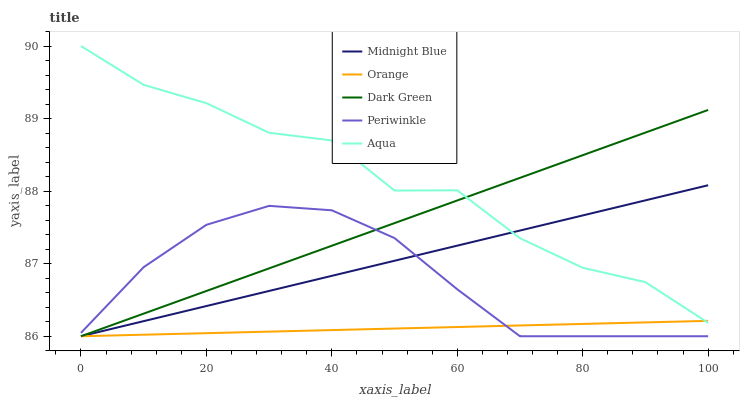Does Orange have the minimum area under the curve?
Answer yes or no. Yes. Does Aqua have the maximum area under the curve?
Answer yes or no. Yes. Does Periwinkle have the minimum area under the curve?
Answer yes or no. No. Does Periwinkle have the maximum area under the curve?
Answer yes or no. No. Is Orange the smoothest?
Answer yes or no. Yes. Is Aqua the roughest?
Answer yes or no. Yes. Is Periwinkle the smoothest?
Answer yes or no. No. Is Periwinkle the roughest?
Answer yes or no. No. Does Orange have the lowest value?
Answer yes or no. Yes. Does Aqua have the lowest value?
Answer yes or no. No. Does Aqua have the highest value?
Answer yes or no. Yes. Does Periwinkle have the highest value?
Answer yes or no. No. Is Periwinkle less than Aqua?
Answer yes or no. Yes. Is Aqua greater than Periwinkle?
Answer yes or no. Yes. Does Aqua intersect Orange?
Answer yes or no. Yes. Is Aqua less than Orange?
Answer yes or no. No. Is Aqua greater than Orange?
Answer yes or no. No. Does Periwinkle intersect Aqua?
Answer yes or no. No. 